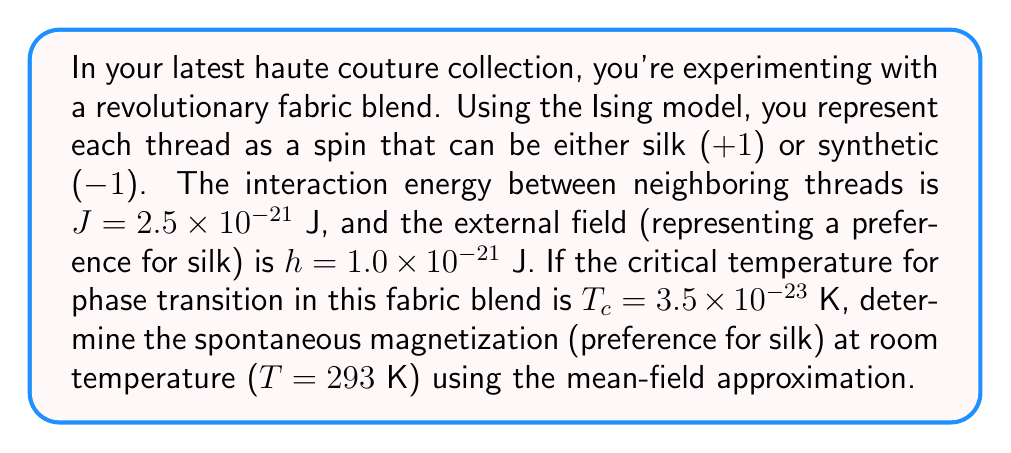Provide a solution to this math problem. Let's approach this step-by-step using the mean-field theory of the Ising model:

1) In the mean-field approximation, the spontaneous magnetization $m$ satisfies the self-consistent equation:

   $$m = \tanh\left(\frac{J z m + h}{k_B T}\right)$$

   where $z$ is the coordination number (typically 4 for a 2D lattice).

2) We're given $J = 2.5 \times 10^{-21}$ J, $h = 1.0 \times 10^{-21}$ J, and $T = 293$ K.

3) The Boltzmann constant $k_B = 1.380649 \times 10^{-23}$ J/K.

4) Substituting these values into the equation:

   $$m = \tanh\left(\frac{(2.5 \times 10^{-21})(4)m + 1.0 \times 10^{-21}}{(1.380649 \times 10^{-23})(293)}\right)$$

5) Simplifying:

   $$m = \tanh(0.1178m + 0.0247)$$

6) This equation can be solved numerically. Using an iterative method or a graphical solution, we find:

   $$m \approx 0.0248$$

7) The critical temperature $T_c$ is given for reference but not needed in this calculation. It would be used to determine if we're above or below the phase transition, but at room temperature we're well above $T_c$, so we're in the disordered phase.

8) The positive value of $m$ indicates a slight preference for silk threads ($+1$ spins) due to the external field $h$.
Answer: $m \approx 0.0248$ 